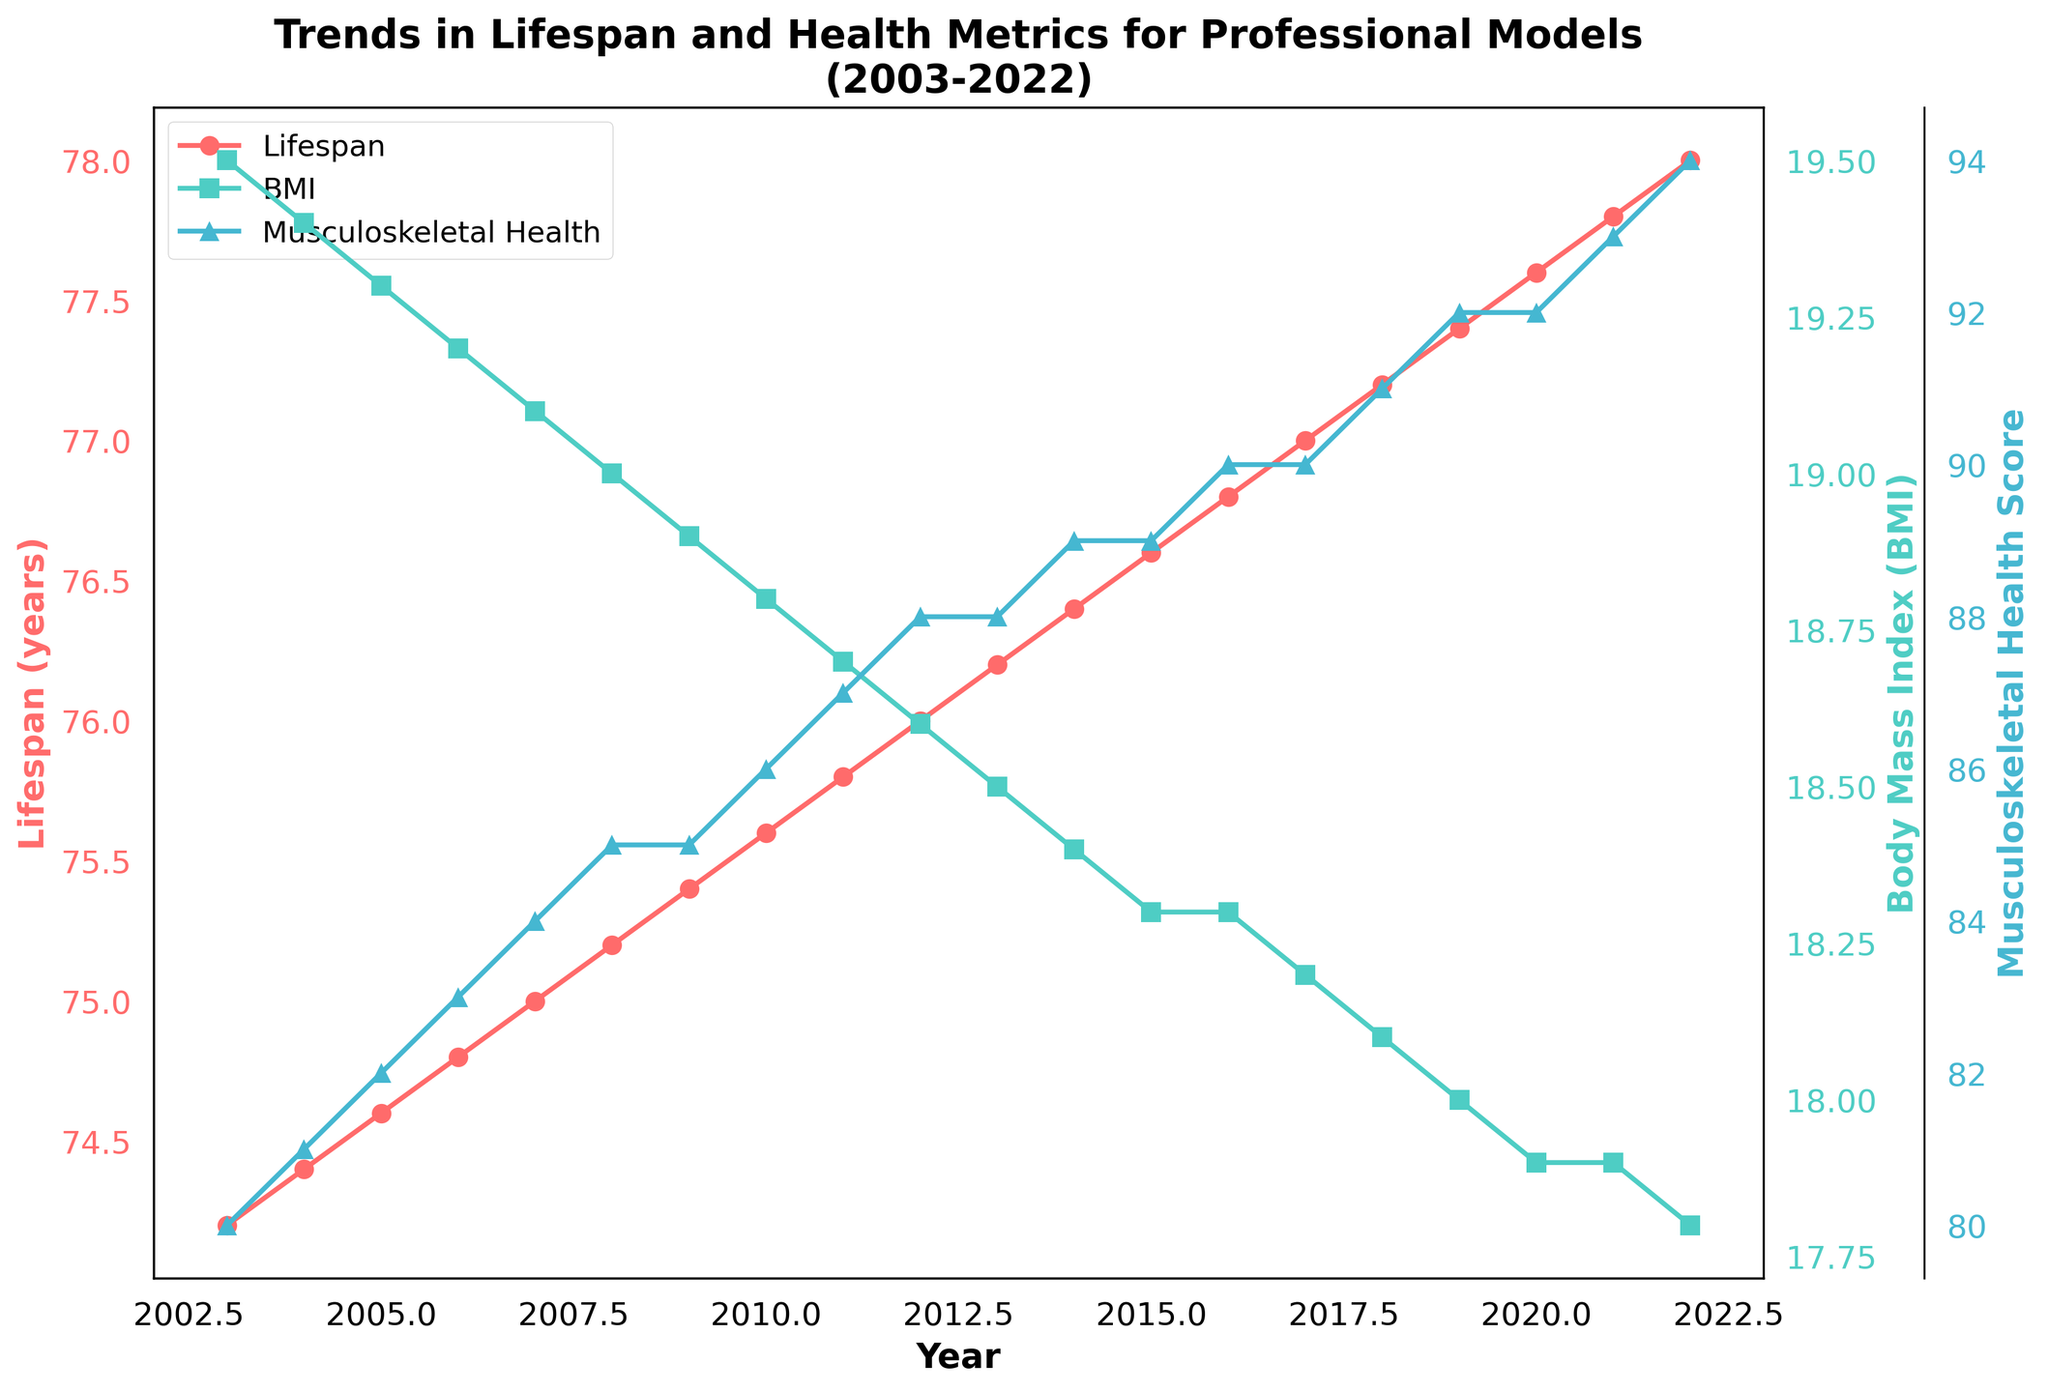What is the title of the plot? The title is located at the top of the plot and it provides a summary of what the figure represents.
Answer: Trends in Lifespan and Health Metrics for Professional Models (2003-2022) Which metric shows an increase in value from 2003 to 2022? Observing the trends of the plotted metrics, the one that consistently shows an upward trend from 2003 to 2022 is identified.
Answer: Lifespan and Musculoskeletal Health Score What is the color used for plotting the Body Mass Index (BMI)? The color for the BMI line is identifiable by its unique color. This color is displayed on the right y-axis label and in the legend.
Answer: Turquoise (color #4ECDC4) How much did the Lifespan increase from 2003 to 2022? Subtract the Lifespan value in 2003 from the Lifespan value in 2022 to find the total increase.
Answer: 78.0 - 74.2 = 3.8 years Which metric improved the most significantly between 2003 and 2022? Comparing the total changes from 2003 and 2022 for each metric, find out which one has the largest positive difference.
Answer: Musculoskeletal Health Score What's the average Lifespan over the period of 2003 to 2022? Calculate the mean of all Lifespan values from the years 2003 to 2022 by summing up the values and dividing by the number of years.
Answer: (74.2 + 74.4 + ... + 78.0) / 20 = 76.1 years During which year did the Stress Levels show a noticeable decline? By following the trend of the Stress Levels line, identify the year corresponding to the first noticeable drop.
Answer: Between 2008 and 2009 How does the Musculoskeletal Health Score in 2022 compare to that in 2003? Compare the Musculoskeletal Health Score in 2022 to the score in 2003.
Answer: Increased by 14 points (2003: 80, 2022: 94) Is the Body Mass Index (BMI) closer to its highest value or lowest value in 2022? Compare the BMI value in 2022 with its highest and lowest values across the years to determine the closeness.
Answer: Closest to its lowest value Which year has the highest Artistic Engagement Score? Check the plotted Artistic Engagement Score for the maximum value and identify the corresponding year(s).
Answer: 2013 - 2022 